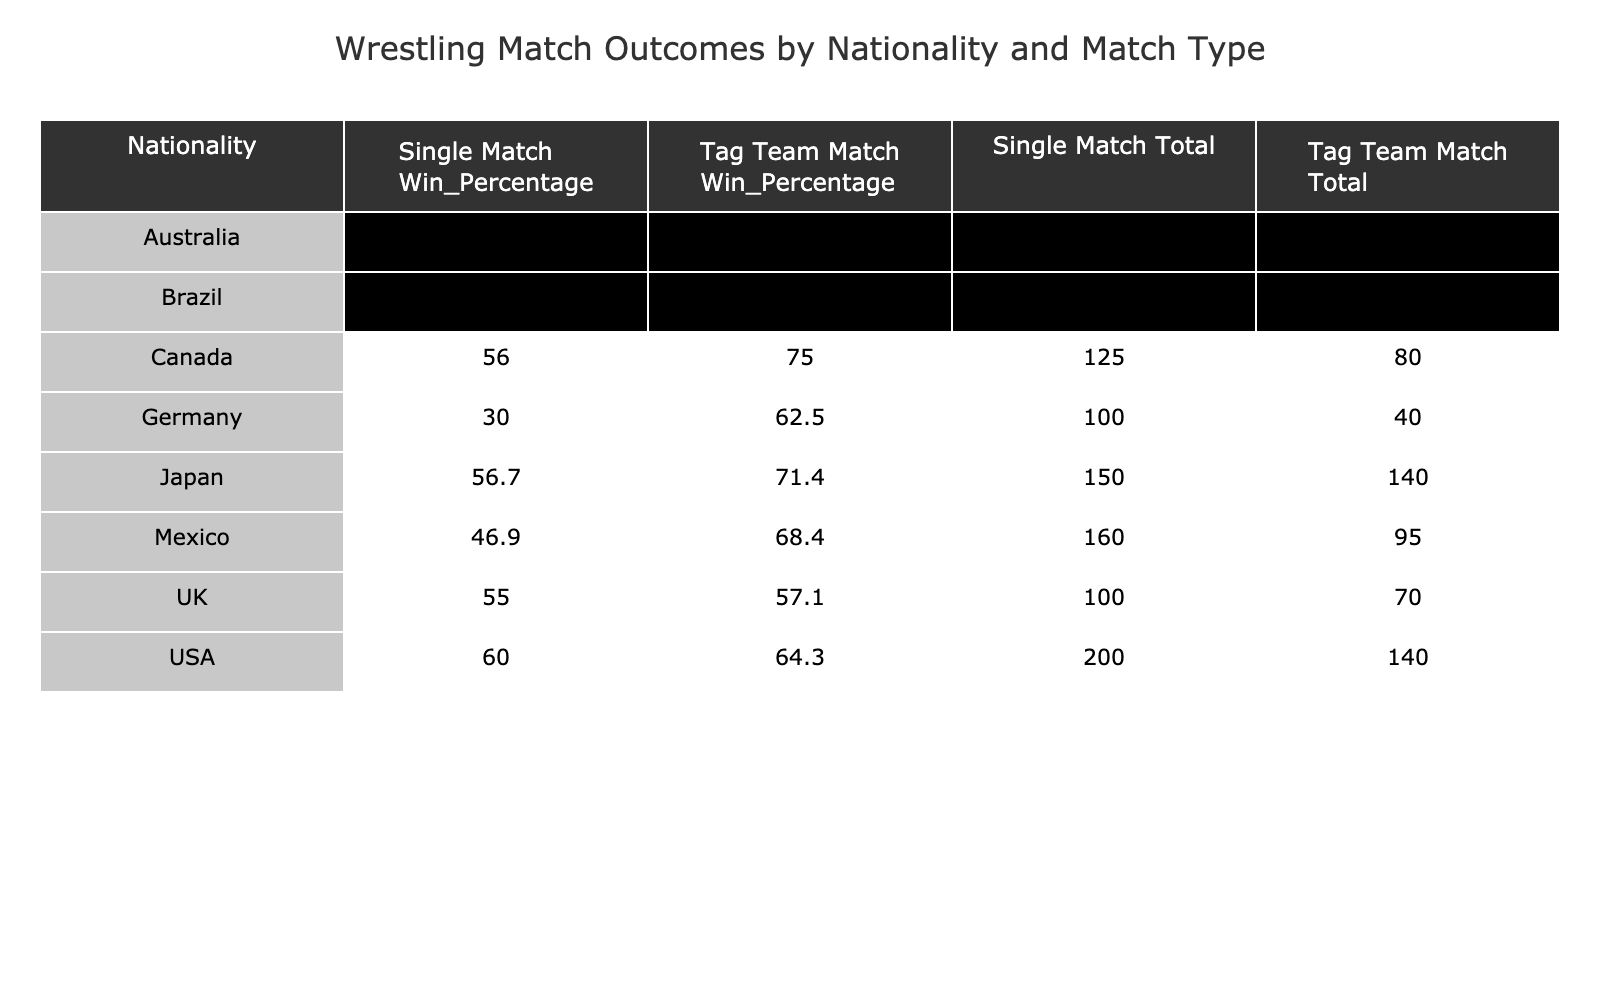What nationality has the highest win percentage in Single Matches? To determine the highest win percentage in Single Matches, we compare the Win Percentages for each nationality in the Single Match category. USA has a win percentage of 60.0, Japan has 56.7, Mexico has 46.8, Canada has 56.4, UK has 55.6, Germany has 30.0, Brazil has 42.3, and Australia has 50.0. The USA has the highest percentage at 60.0.
Answer: USA Which nationality has the lowest total matches in Tag Team Matches? To find the lowest total matches in Tag Team Matches, we look at the Total column for each nationality in the Tag Team Match category. The totals are: USA 140, Japan 140, Mexico 95, Canada 80, UK 70, Germany 40, Brazil 50, and Australia 60. Canada has the lowest total with 80 matches.
Answer: Canada Is it true that Japanese wrestlers have more wins than losses in Tag Team Matches? We check the wins and losses for Japan in Tag Team Matches. Japan has 100 wins and 40 losses, which indicates that they have more wins than losses (100 > 40). Therefore, the statement is true.
Answer: Yes What is the difference between wins and losses for Mexican wrestlers in Single Matches? For Mexican wrestlers in Single Matches, we have 75 wins and 85 losses. To find the difference, we subtract the wins from the losses: 85 - 75 = 10, indicating that there are 10 more losses than wins for Mexican wrestlers in this category.
Answer: 10 What is the total number of matches played by UK wrestlers across both match types? We sum the Total matches for the UK wrestlers in both Single and Tag Team Matches. UK has a Total of 100 matches in Single Matches and 70 matches in Tag Team Matches. Therefore, the total number of matches is 100 + 70 = 170.
Answer: 170 